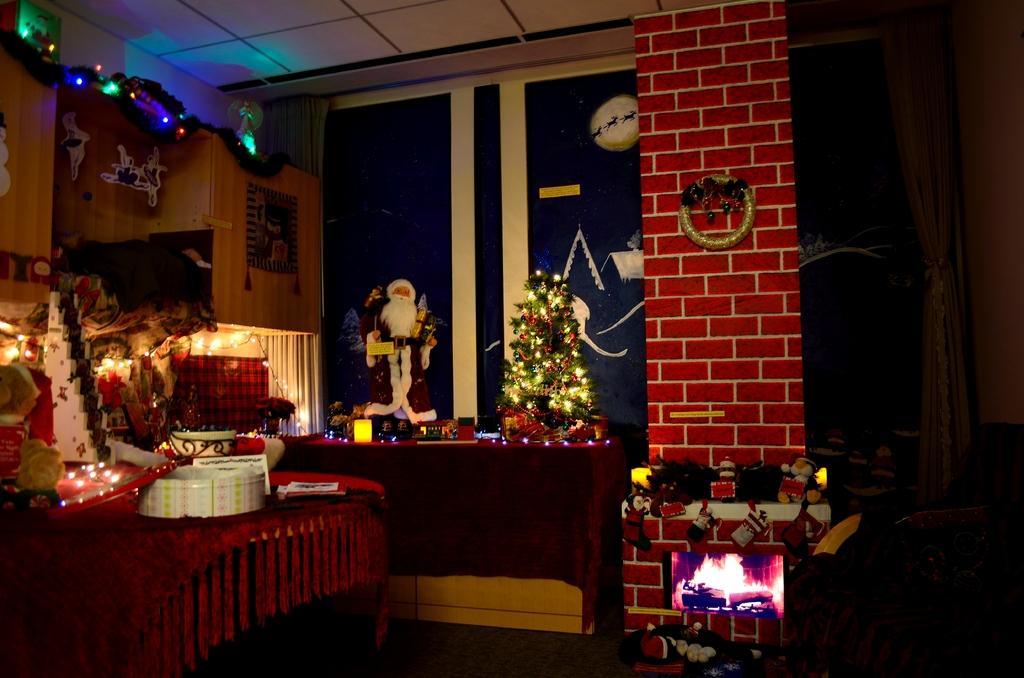Please provide a concise description of this image. This is an inside view. In this room we can see two tables. On this table Christmas tree and few decorations are there. The room is decorated with a color full lights. On the right side of the image we can see some toys. In the background there is a white color curtain. 